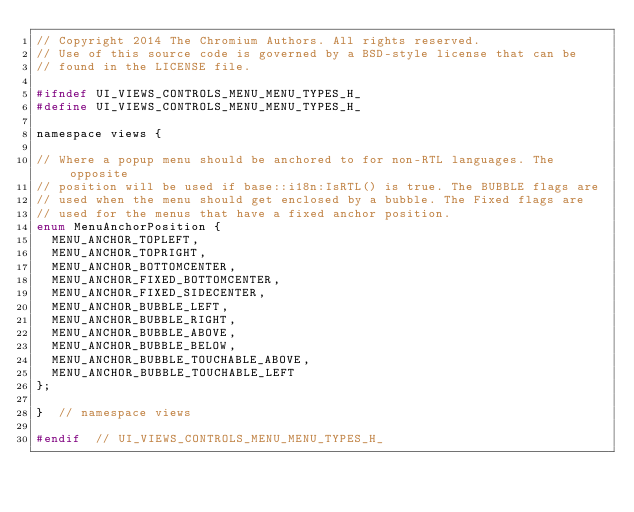Convert code to text. <code><loc_0><loc_0><loc_500><loc_500><_C_>// Copyright 2014 The Chromium Authors. All rights reserved.
// Use of this source code is governed by a BSD-style license that can be
// found in the LICENSE file.

#ifndef UI_VIEWS_CONTROLS_MENU_MENU_TYPES_H_
#define UI_VIEWS_CONTROLS_MENU_MENU_TYPES_H_

namespace views {

// Where a popup menu should be anchored to for non-RTL languages. The opposite
// position will be used if base::i18n:IsRTL() is true. The BUBBLE flags are
// used when the menu should get enclosed by a bubble. The Fixed flags are
// used for the menus that have a fixed anchor position.
enum MenuAnchorPosition {
  MENU_ANCHOR_TOPLEFT,
  MENU_ANCHOR_TOPRIGHT,
  MENU_ANCHOR_BOTTOMCENTER,
  MENU_ANCHOR_FIXED_BOTTOMCENTER,
  MENU_ANCHOR_FIXED_SIDECENTER,
  MENU_ANCHOR_BUBBLE_LEFT,
  MENU_ANCHOR_BUBBLE_RIGHT,
  MENU_ANCHOR_BUBBLE_ABOVE,
  MENU_ANCHOR_BUBBLE_BELOW,
  MENU_ANCHOR_BUBBLE_TOUCHABLE_ABOVE,
  MENU_ANCHOR_BUBBLE_TOUCHABLE_LEFT
};

}  // namespace views

#endif  // UI_VIEWS_CONTROLS_MENU_MENU_TYPES_H_
</code> 